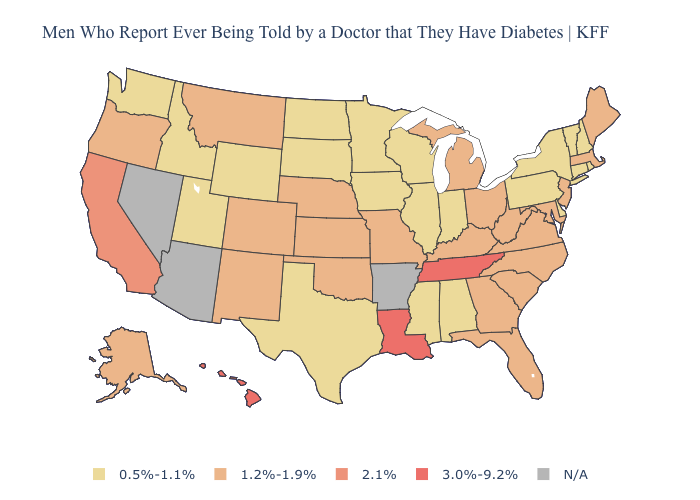What is the highest value in the Northeast ?
Short answer required. 1.2%-1.9%. Is the legend a continuous bar?
Write a very short answer. No. Does Vermont have the lowest value in the USA?
Give a very brief answer. Yes. What is the highest value in states that border Texas?
Answer briefly. 3.0%-9.2%. Name the states that have a value in the range 3.0%-9.2%?
Short answer required. Hawaii, Louisiana, Tennessee. What is the value of Tennessee?
Concise answer only. 3.0%-9.2%. What is the highest value in states that border Maine?
Answer briefly. 0.5%-1.1%. What is the highest value in states that border Arkansas?
Quick response, please. 3.0%-9.2%. What is the value of Alaska?
Be succinct. 1.2%-1.9%. What is the highest value in the MidWest ?
Give a very brief answer. 1.2%-1.9%. What is the highest value in states that border Alabama?
Keep it brief. 3.0%-9.2%. What is the value of West Virginia?
Answer briefly. 1.2%-1.9%. Among the states that border Maine , which have the lowest value?
Concise answer only. New Hampshire. Name the states that have a value in the range 3.0%-9.2%?
Be succinct. Hawaii, Louisiana, Tennessee. What is the value of Wisconsin?
Answer briefly. 0.5%-1.1%. 